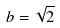Convert formula to latex. <formula><loc_0><loc_0><loc_500><loc_500>b = { \sqrt { 2 } }</formula> 